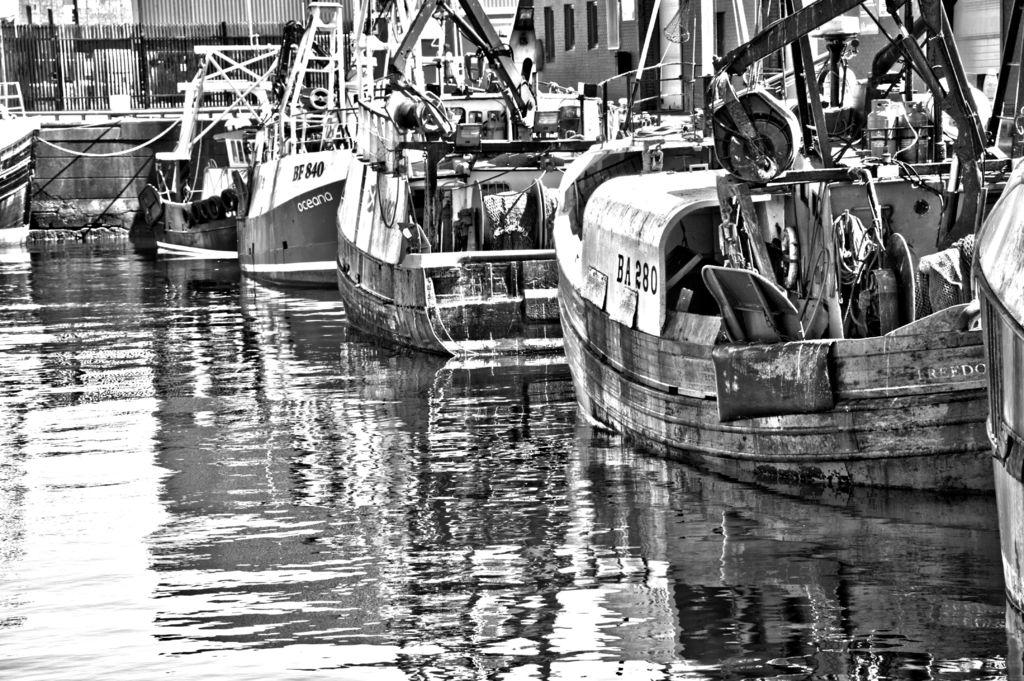What type of vehicles are in the water in the image? There are ships in the water in the image. What is the color scheme of the image? The image is in black and white mode. What type of barrier can be seen in the image? There is fencing visible in the image. What type of desk is visible in the image? There is no desk present in the image. What type of business is being conducted in the image? The image does not depict any business activities. 